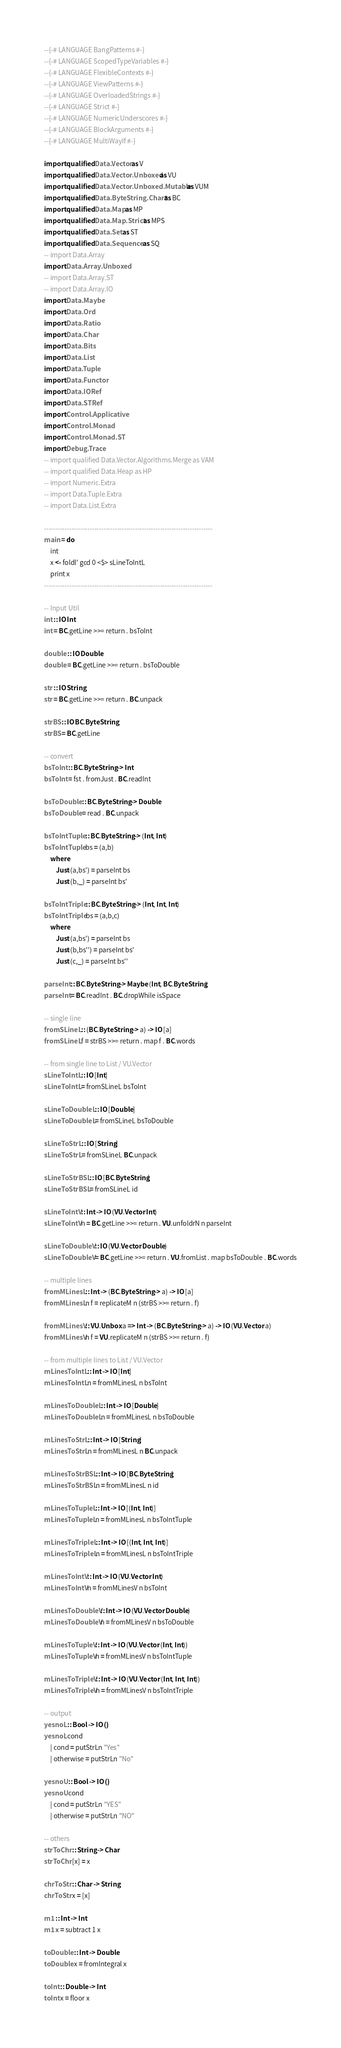<code> <loc_0><loc_0><loc_500><loc_500><_Haskell_>--{-# LANGUAGE BangPatterns #-}
--{-# LANGUAGE ScopedTypeVariables #-}
--{-# LANGUAGE FlexibleContexts #-}
--{-# LANGUAGE ViewPatterns #-}
--{-# LANGUAGE OverloadedStrings #-}
--{-# LANGUAGE Strict #-}
--{-# LANGUAGE NumericUnderscores #-}
--{-# LANGUAGE BlockArguments #-}
--{-# LANGUAGE MultiWayIf #-}

import qualified Data.Vector as V
import qualified Data.Vector.Unboxed as VU
import qualified Data.Vector.Unboxed.Mutable as VUM
import qualified Data.ByteString.Char8 as BC
import qualified Data.Map as MP
import qualified Data.Map.Strict as MPS
import qualified Data.Set as ST
import qualified Data.Sequence as SQ
-- import Data.Array
import Data.Array.Unboxed
-- import Data.Array.ST
-- import Data.Array.IO
import Data.Maybe
import Data.Ord
import Data.Ratio
import Data.Char
import Data.Bits
import Data.List
import Data.Tuple
import Data.Functor
import Data.IORef
import Data.STRef
import Control.Applicative
import Control.Monad
import Control.Monad.ST
import Debug.Trace
-- import qualified Data.Vector.Algorithms.Merge as VAM
-- import qualified Data.Heap as HP
-- import Numeric.Extra
-- import Data.Tuple.Extra
-- import Data.List.Extra

--------------------------------------------------------------------------
main = do
    int
    x <- foldl' gcd 0 <$> sLineToIntL
    print x
--------------------------------------------------------------------------

-- Input Util
int :: IO Int
int = BC.getLine >>= return . bsToInt

double :: IO Double
double = BC.getLine >>= return . bsToDouble

str :: IO String
str = BC.getLine >>= return . BC.unpack

strBS :: IO BC.ByteString
strBS = BC.getLine

-- convert
bsToInt :: BC.ByteString -> Int
bsToInt = fst . fromJust . BC.readInt

bsToDouble :: BC.ByteString -> Double
bsToDouble = read . BC.unpack

bsToIntTuple :: BC.ByteString -> (Int, Int)
bsToIntTuple bs = (a,b)
    where
        Just (a,bs') = parseInt bs
        Just (b,_) = parseInt bs'

bsToIntTriple :: BC.ByteString -> (Int, Int, Int)
bsToIntTriple bs = (a,b,c)
    where
        Just (a,bs') = parseInt bs
        Just (b,bs'') = parseInt bs'
        Just (c,_) = parseInt bs''

parseInt :: BC.ByteString -> Maybe (Int, BC.ByteString)
parseInt = BC.readInt . BC.dropWhile isSpace

-- single line
fromSLineL :: (BC.ByteString -> a) -> IO [a]
fromSLineL f = strBS >>= return . map f . BC.words

-- from single line to List / VU.Vector 
sLineToIntL :: IO [Int]
sLineToIntL = fromSLineL bsToInt

sLineToDoubleL :: IO [Double]
sLineToDoubleL = fromSLineL bsToDouble

sLineToStrL :: IO [String]
sLineToStrL = fromSLineL BC.unpack

sLineToStrBSL :: IO [BC.ByteString]
sLineToStrBSL = fromSLineL id 

sLineToIntV :: Int -> IO (VU.Vector Int)
sLineToIntV n = BC.getLine >>= return . VU.unfoldrN n parseInt

sLineToDoubleV :: IO (VU.Vector Double)
sLineToDoubleV = BC.getLine >>= return . VU.fromList . map bsToDouble . BC.words

-- multiple lines
fromMLinesL :: Int -> (BC.ByteString -> a) -> IO [a]
fromMLinesL n f = replicateM n (strBS >>= return . f)

fromMLinesV :: VU.Unbox a => Int -> (BC.ByteString -> a) -> IO (VU.Vector a)
fromMLinesV n f = VU.replicateM n (strBS >>= return . f)

-- from multiple lines to List / VU.Vector
mLinesToIntL :: Int -> IO [Int]
mLinesToIntL n = fromMLinesL n bsToInt

mLinesToDoubleL :: Int -> IO [Double]
mLinesToDoubleL n = fromMLinesL n bsToDouble

mLinesToStrL :: Int -> IO [String]
mLinesToStrL n = fromMLinesL n BC.unpack

mLinesToStrBSL :: Int -> IO [BC.ByteString]
mLinesToStrBSL n = fromMLinesL n id

mLinesToTupleL :: Int -> IO [(Int, Int)]
mLinesToTupleL n = fromMLinesL n bsToIntTuple

mLinesToTripleL :: Int -> IO [(Int, Int, Int)]
mLinesToTripleL n = fromMLinesL n bsToIntTriple

mLinesToIntV :: Int -> IO (VU.Vector Int)
mLinesToIntV n = fromMLinesV n bsToInt

mLinesToDoubleV :: Int -> IO (VU.Vector Double)
mLinesToDoubleV n = fromMLinesV n bsToDouble

mLinesToTupleV :: Int -> IO (VU.Vector (Int, Int))
mLinesToTupleV n = fromMLinesV n bsToIntTuple
    
mLinesToTripleV :: Int -> IO (VU.Vector (Int, Int, Int))
mLinesToTripleV n = fromMLinesV n bsToIntTriple

-- output
yesnoL :: Bool -> IO ()
yesnoL cond
    | cond = putStrLn "Yes"
    | otherwise = putStrLn "No"

yesnoU :: Bool -> IO ()
yesnoU cond
    | cond = putStrLn "YES"
    | otherwise = putStrLn "NO"

-- others
strToChr :: String -> Char
strToChr [x] = x

chrToStr :: Char -> String
chrToStr x = [x]

m1 :: Int -> Int
m1 x = subtract 1 x

toDouble :: Int -> Double
toDouble x = fromIntegral x

toInt :: Double -> Int
toInt x = floor x
</code> 